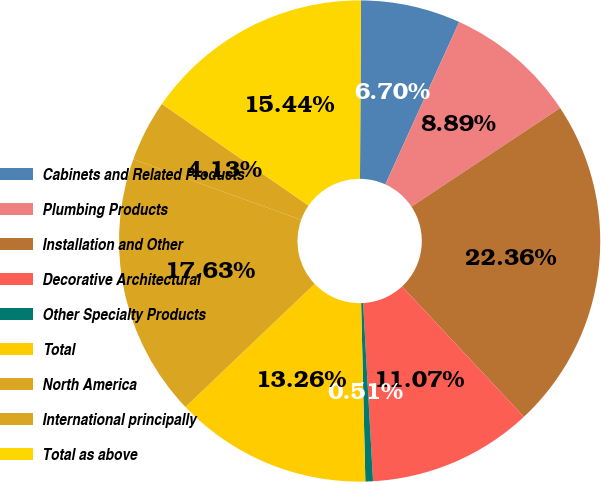Convert chart. <chart><loc_0><loc_0><loc_500><loc_500><pie_chart><fcel>Cabinets and Related Products<fcel>Plumbing Products<fcel>Installation and Other<fcel>Decorative Architectural<fcel>Other Specialty Products<fcel>Total<fcel>North America<fcel>International principally<fcel>Total as above<nl><fcel>6.7%<fcel>8.89%<fcel>22.36%<fcel>11.07%<fcel>0.51%<fcel>13.26%<fcel>17.63%<fcel>4.13%<fcel>15.44%<nl></chart> 